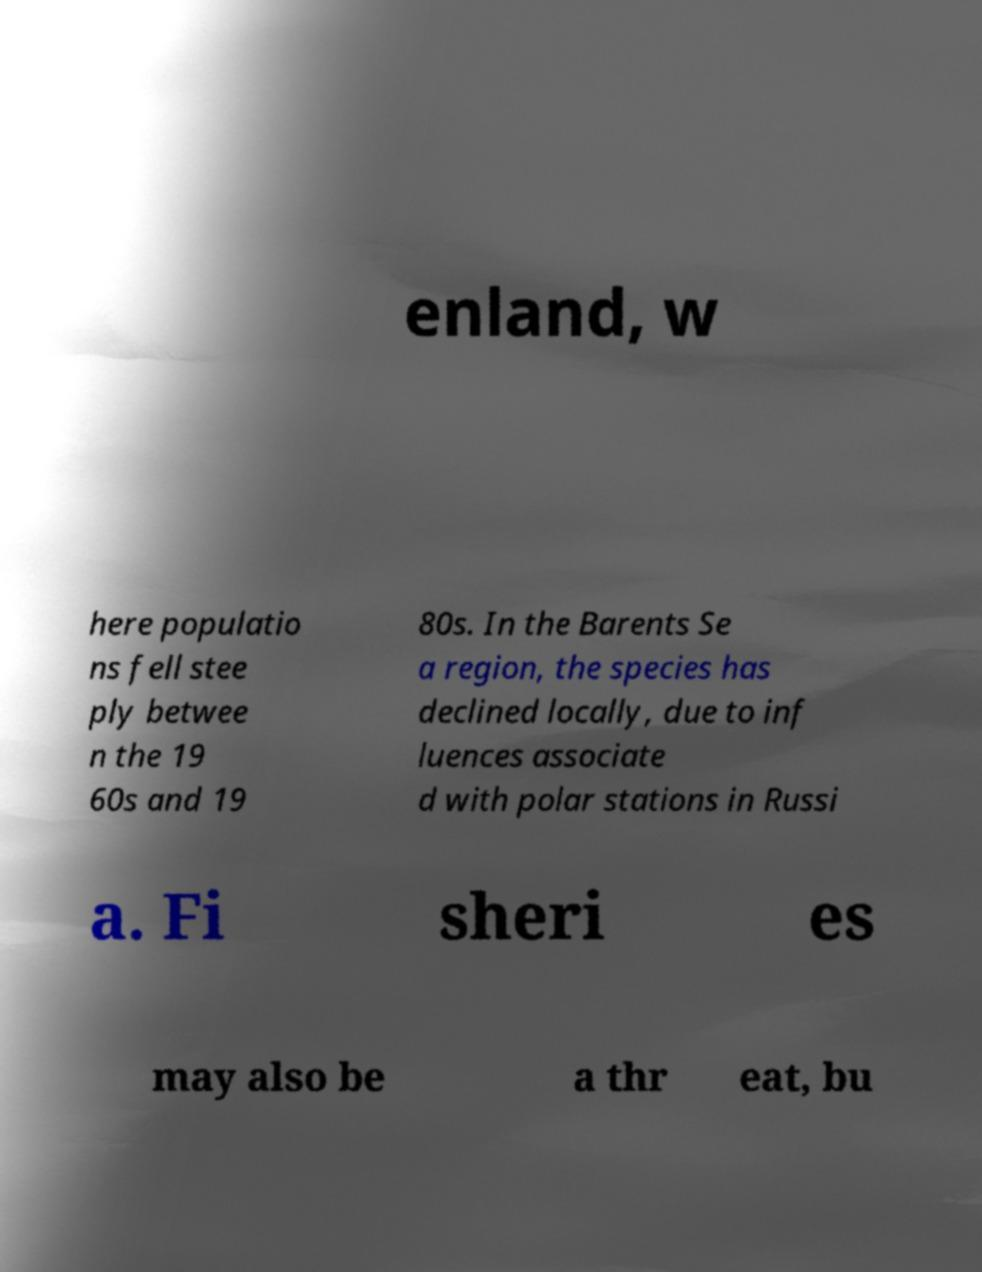I need the written content from this picture converted into text. Can you do that? enland, w here populatio ns fell stee ply betwee n the 19 60s and 19 80s. In the Barents Se a region, the species has declined locally, due to inf luences associate d with polar stations in Russi a. Fi sheri es may also be a thr eat, bu 